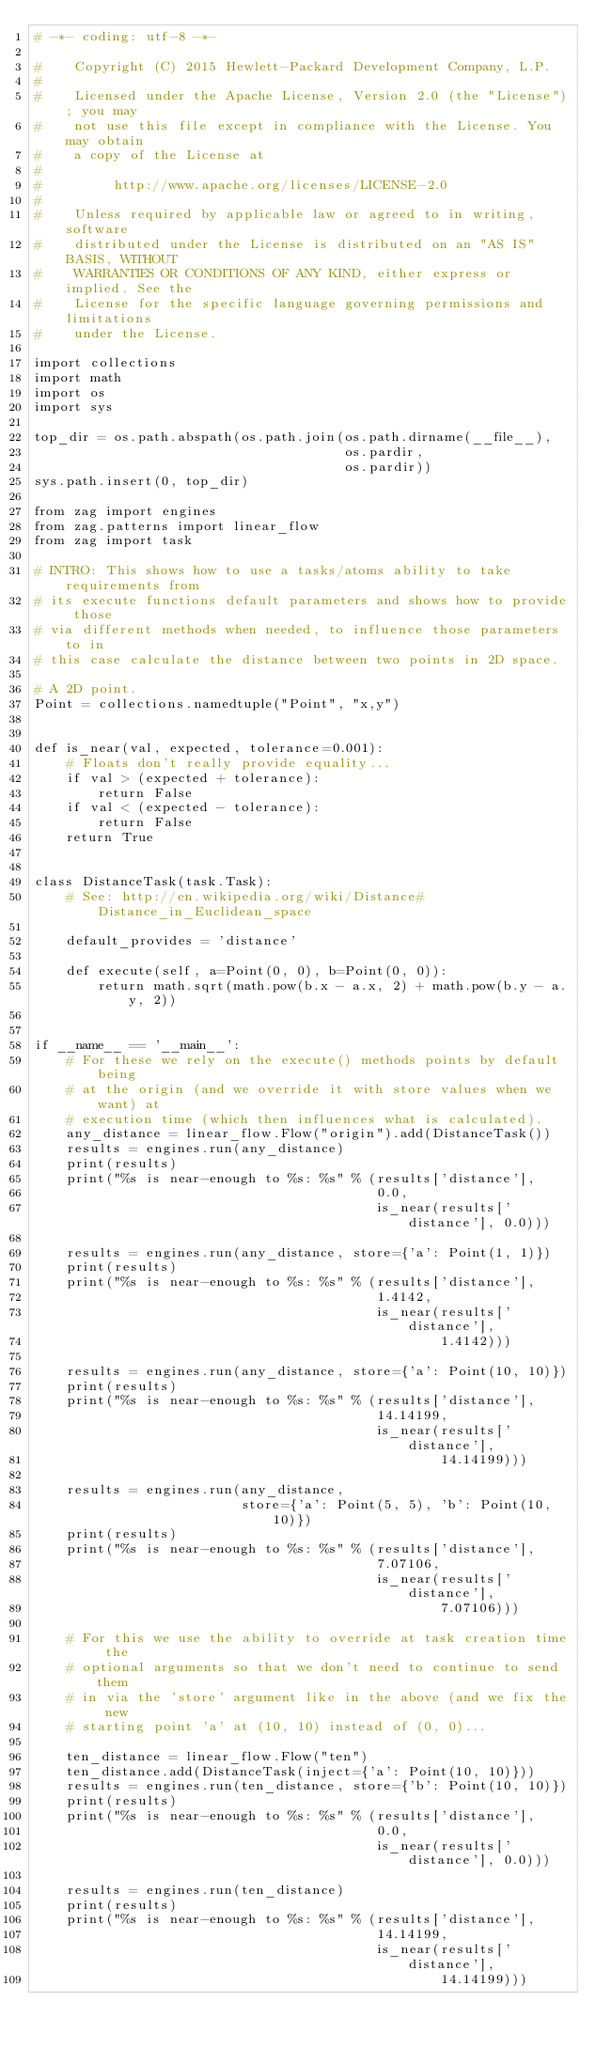Convert code to text. <code><loc_0><loc_0><loc_500><loc_500><_Python_># -*- coding: utf-8 -*-

#    Copyright (C) 2015 Hewlett-Packard Development Company, L.P.
#
#    Licensed under the Apache License, Version 2.0 (the "License"); you may
#    not use this file except in compliance with the License. You may obtain
#    a copy of the License at
#
#         http://www.apache.org/licenses/LICENSE-2.0
#
#    Unless required by applicable law or agreed to in writing, software
#    distributed under the License is distributed on an "AS IS" BASIS, WITHOUT
#    WARRANTIES OR CONDITIONS OF ANY KIND, either express or implied. See the
#    License for the specific language governing permissions and limitations
#    under the License.

import collections
import math
import os
import sys

top_dir = os.path.abspath(os.path.join(os.path.dirname(__file__),
                                       os.pardir,
                                       os.pardir))
sys.path.insert(0, top_dir)

from zag import engines
from zag.patterns import linear_flow
from zag import task

# INTRO: This shows how to use a tasks/atoms ability to take requirements from
# its execute functions default parameters and shows how to provide those
# via different methods when needed, to influence those parameters to in
# this case calculate the distance between two points in 2D space.

# A 2D point.
Point = collections.namedtuple("Point", "x,y")


def is_near(val, expected, tolerance=0.001):
    # Floats don't really provide equality...
    if val > (expected + tolerance):
        return False
    if val < (expected - tolerance):
        return False
    return True


class DistanceTask(task.Task):
    # See: http://en.wikipedia.org/wiki/Distance#Distance_in_Euclidean_space

    default_provides = 'distance'

    def execute(self, a=Point(0, 0), b=Point(0, 0)):
        return math.sqrt(math.pow(b.x - a.x, 2) + math.pow(b.y - a.y, 2))


if __name__ == '__main__':
    # For these we rely on the execute() methods points by default being
    # at the origin (and we override it with store values when we want) at
    # execution time (which then influences what is calculated).
    any_distance = linear_flow.Flow("origin").add(DistanceTask())
    results = engines.run(any_distance)
    print(results)
    print("%s is near-enough to %s: %s" % (results['distance'],
                                           0.0,
                                           is_near(results['distance'], 0.0)))

    results = engines.run(any_distance, store={'a': Point(1, 1)})
    print(results)
    print("%s is near-enough to %s: %s" % (results['distance'],
                                           1.4142,
                                           is_near(results['distance'],
                                                   1.4142)))

    results = engines.run(any_distance, store={'a': Point(10, 10)})
    print(results)
    print("%s is near-enough to %s: %s" % (results['distance'],
                                           14.14199,
                                           is_near(results['distance'],
                                                   14.14199)))

    results = engines.run(any_distance,
                          store={'a': Point(5, 5), 'b': Point(10, 10)})
    print(results)
    print("%s is near-enough to %s: %s" % (results['distance'],
                                           7.07106,
                                           is_near(results['distance'],
                                                   7.07106)))

    # For this we use the ability to override at task creation time the
    # optional arguments so that we don't need to continue to send them
    # in via the 'store' argument like in the above (and we fix the new
    # starting point 'a' at (10, 10) instead of (0, 0)...

    ten_distance = linear_flow.Flow("ten")
    ten_distance.add(DistanceTask(inject={'a': Point(10, 10)}))
    results = engines.run(ten_distance, store={'b': Point(10, 10)})
    print(results)
    print("%s is near-enough to %s: %s" % (results['distance'],
                                           0.0,
                                           is_near(results['distance'], 0.0)))

    results = engines.run(ten_distance)
    print(results)
    print("%s is near-enough to %s: %s" % (results['distance'],
                                           14.14199,
                                           is_near(results['distance'],
                                                   14.14199)))
</code> 